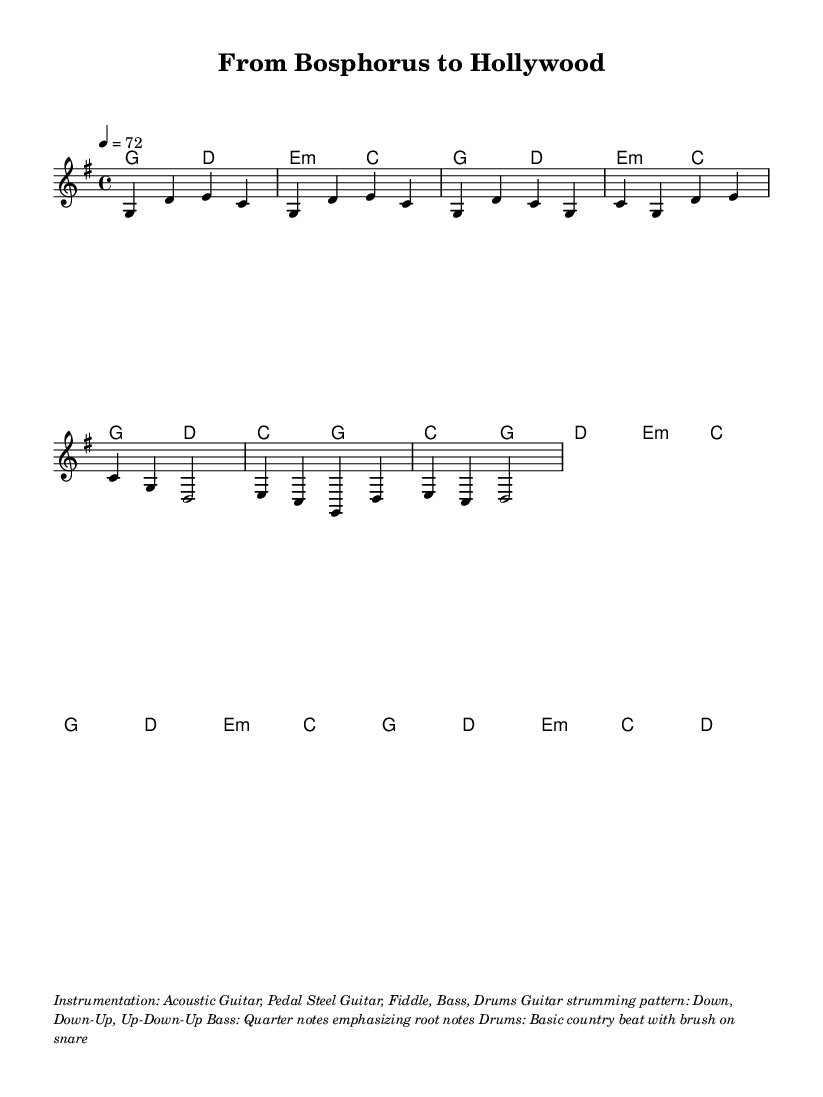What is the key signature of this music? The key signature is G major, which has one sharp (F#) indicated in the score.
Answer: G major What is the time signature of this music? The time signature shown in the score is 4/4, meaning there are four beats in each measure.
Answer: 4/4 What is the tempo marking for this piece? The tempo marking in the score indicates a speed of 72 beats per minute, meaning that there should be 72 quarter-note beats in one minute.
Answer: 72 How many measures are present in the chorus section? The chorus section consists of four measures as can be counted in the melody portion where the chorus begins and ends clearly with a repetitive structure.
Answer: 4 measures What instrumentation is specified in the markup? The instrumentation section lists Acoustic Guitar, Pedal Steel Guitar, Fiddle, Bass, and Drums, providing insight into the ensemble that performs this piece.
Answer: Acoustic Guitar, Pedal Steel Guitar, Fiddle, Bass, Drums What strumming pattern is indicated for the guitar? The score provides a strumming pattern described as Down, Down-Up, Up-Down-Up, which is typical for rhythm in country rock music.
Answer: Down, Down-Up, Up-Down-Up Which chord is first in the bridge section? The first chord in the bridge is E minor, as seen in the harmonies section of the score directly at the start of the bridge measures.
Answer: E minor 